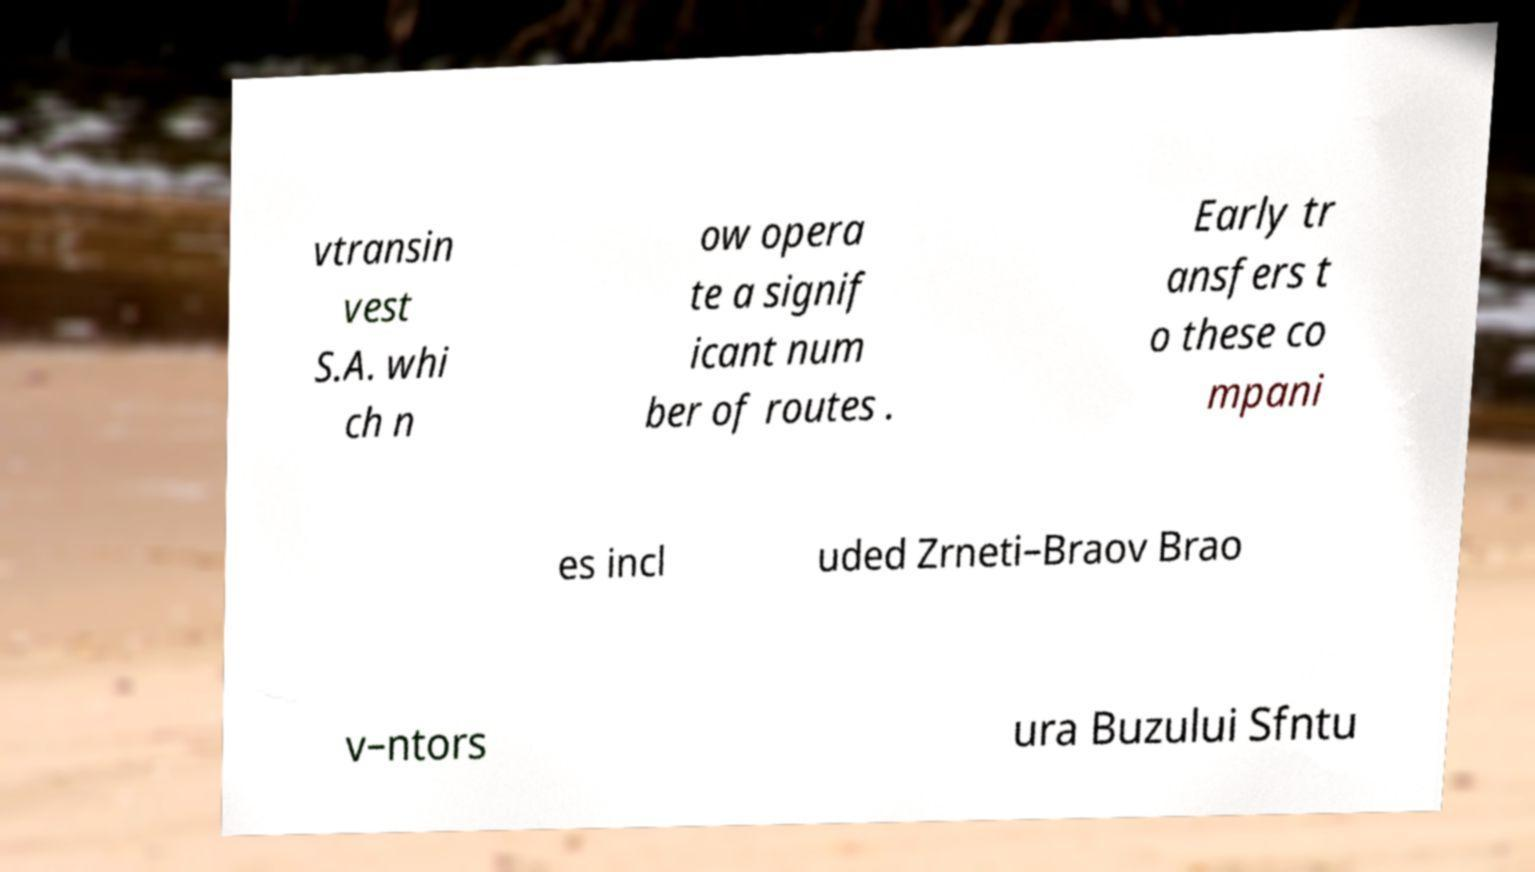I need the written content from this picture converted into text. Can you do that? vtransin vest S.A. whi ch n ow opera te a signif icant num ber of routes . Early tr ansfers t o these co mpani es incl uded Zrneti–Braov Brao v–ntors ura Buzului Sfntu 